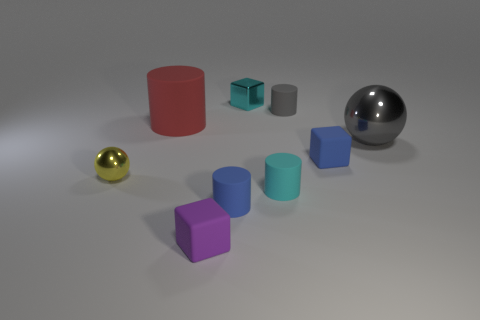What number of blue matte cubes are there?
Provide a succinct answer. 1. What number of small blocks are the same color as the big ball?
Offer a very short reply. 0. There is a big thing that is left of the small gray rubber cylinder; is it the same shape as the small blue object in front of the tiny cyan cylinder?
Your response must be concise. Yes. What is the color of the cylinder that is in front of the small cyan thing in front of the large red thing that is on the left side of the cyan matte object?
Your response must be concise. Blue. What is the color of the tiny thing that is on the left side of the tiny purple cube?
Ensure brevity in your answer.  Yellow. There is another thing that is the same size as the red matte thing; what color is it?
Your answer should be very brief. Gray. Is the yellow metal ball the same size as the cyan metallic thing?
Provide a succinct answer. Yes. What number of tiny cyan things are in front of the small ball?
Your answer should be very brief. 1. What number of things are shiny objects that are behind the yellow object or cyan cubes?
Your answer should be compact. 2. Is the number of tiny shiny objects that are to the right of the cyan block greater than the number of small gray cylinders in front of the gray metal object?
Provide a short and direct response. No. 